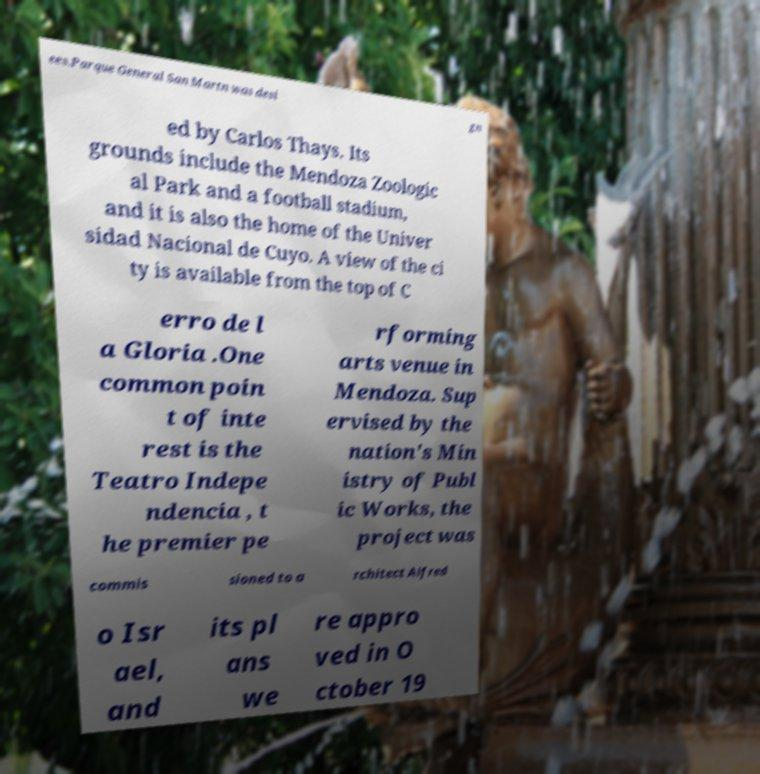Could you extract and type out the text from this image? ees.Parque General San Martn was desi gn ed by Carlos Thays. Its grounds include the Mendoza Zoologic al Park and a football stadium, and it is also the home of the Univer sidad Nacional de Cuyo. A view of the ci ty is available from the top of C erro de l a Gloria .One common poin t of inte rest is the Teatro Indepe ndencia , t he premier pe rforming arts venue in Mendoza. Sup ervised by the nation's Min istry of Publ ic Works, the project was commis sioned to a rchitect Alfred o Isr ael, and its pl ans we re appro ved in O ctober 19 